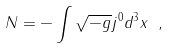Convert formula to latex. <formula><loc_0><loc_0><loc_500><loc_500>N = - \int \sqrt { - g } j ^ { 0 } d ^ { 3 } x \ ,</formula> 